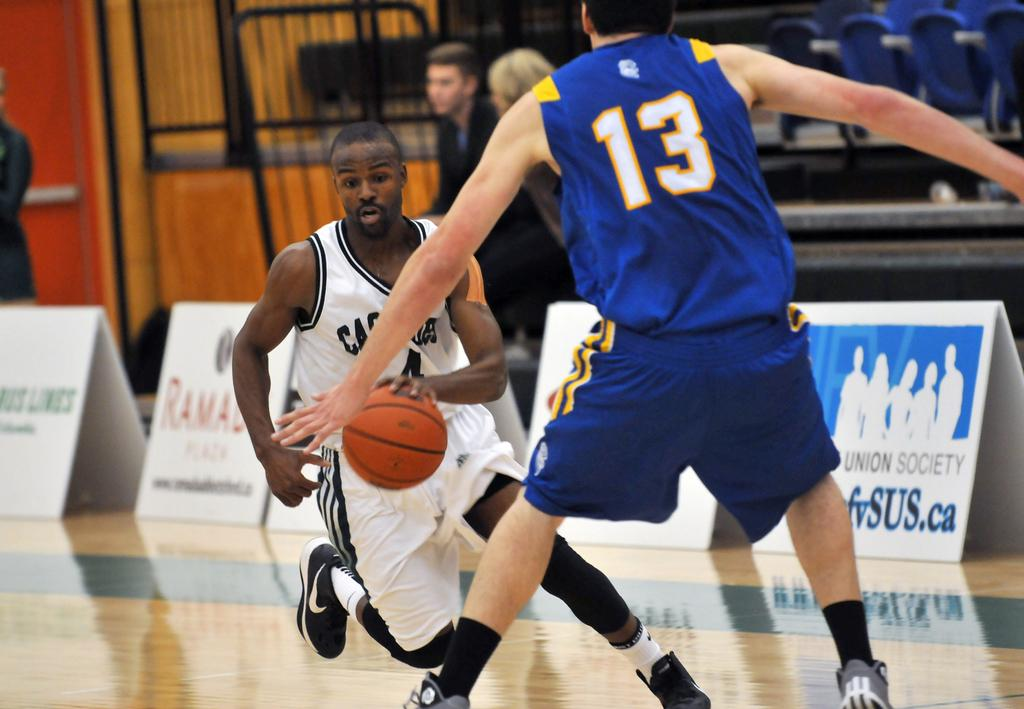<image>
Describe the image concisely. some people playing basketball and a person wearing the number 13 